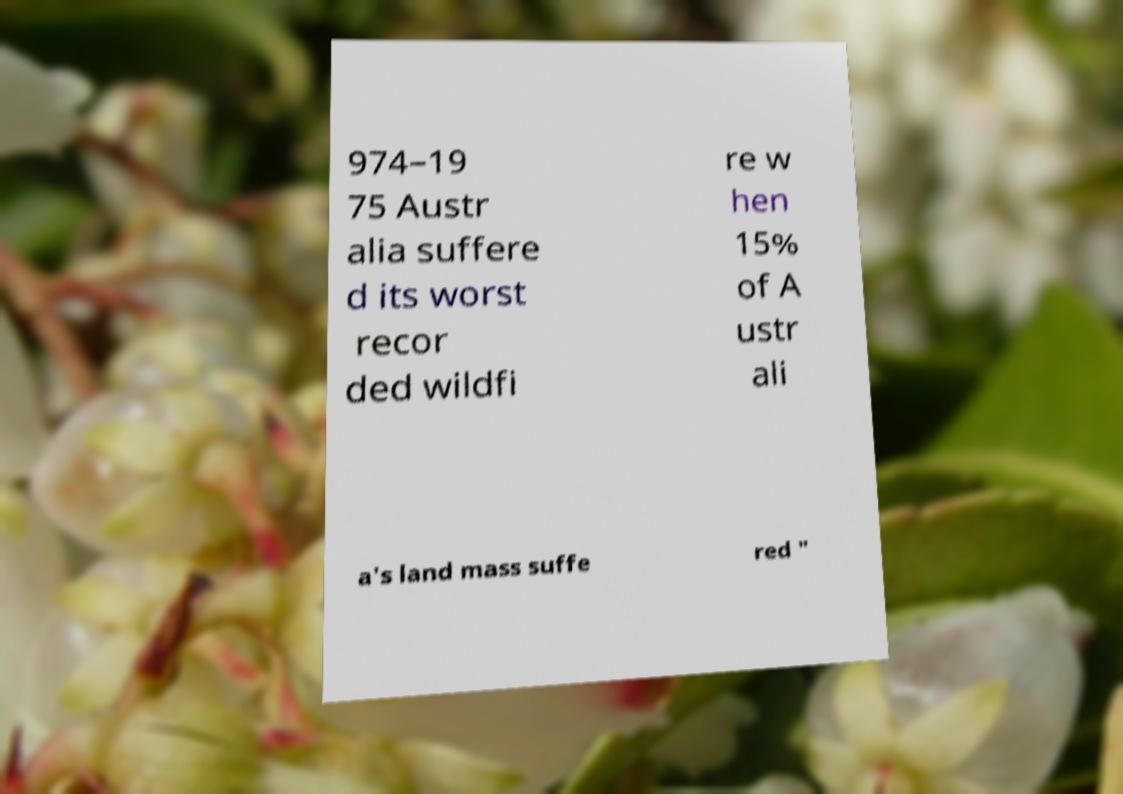Could you extract and type out the text from this image? 974–19 75 Austr alia suffere d its worst recor ded wildfi re w hen 15% of A ustr ali a's land mass suffe red " 